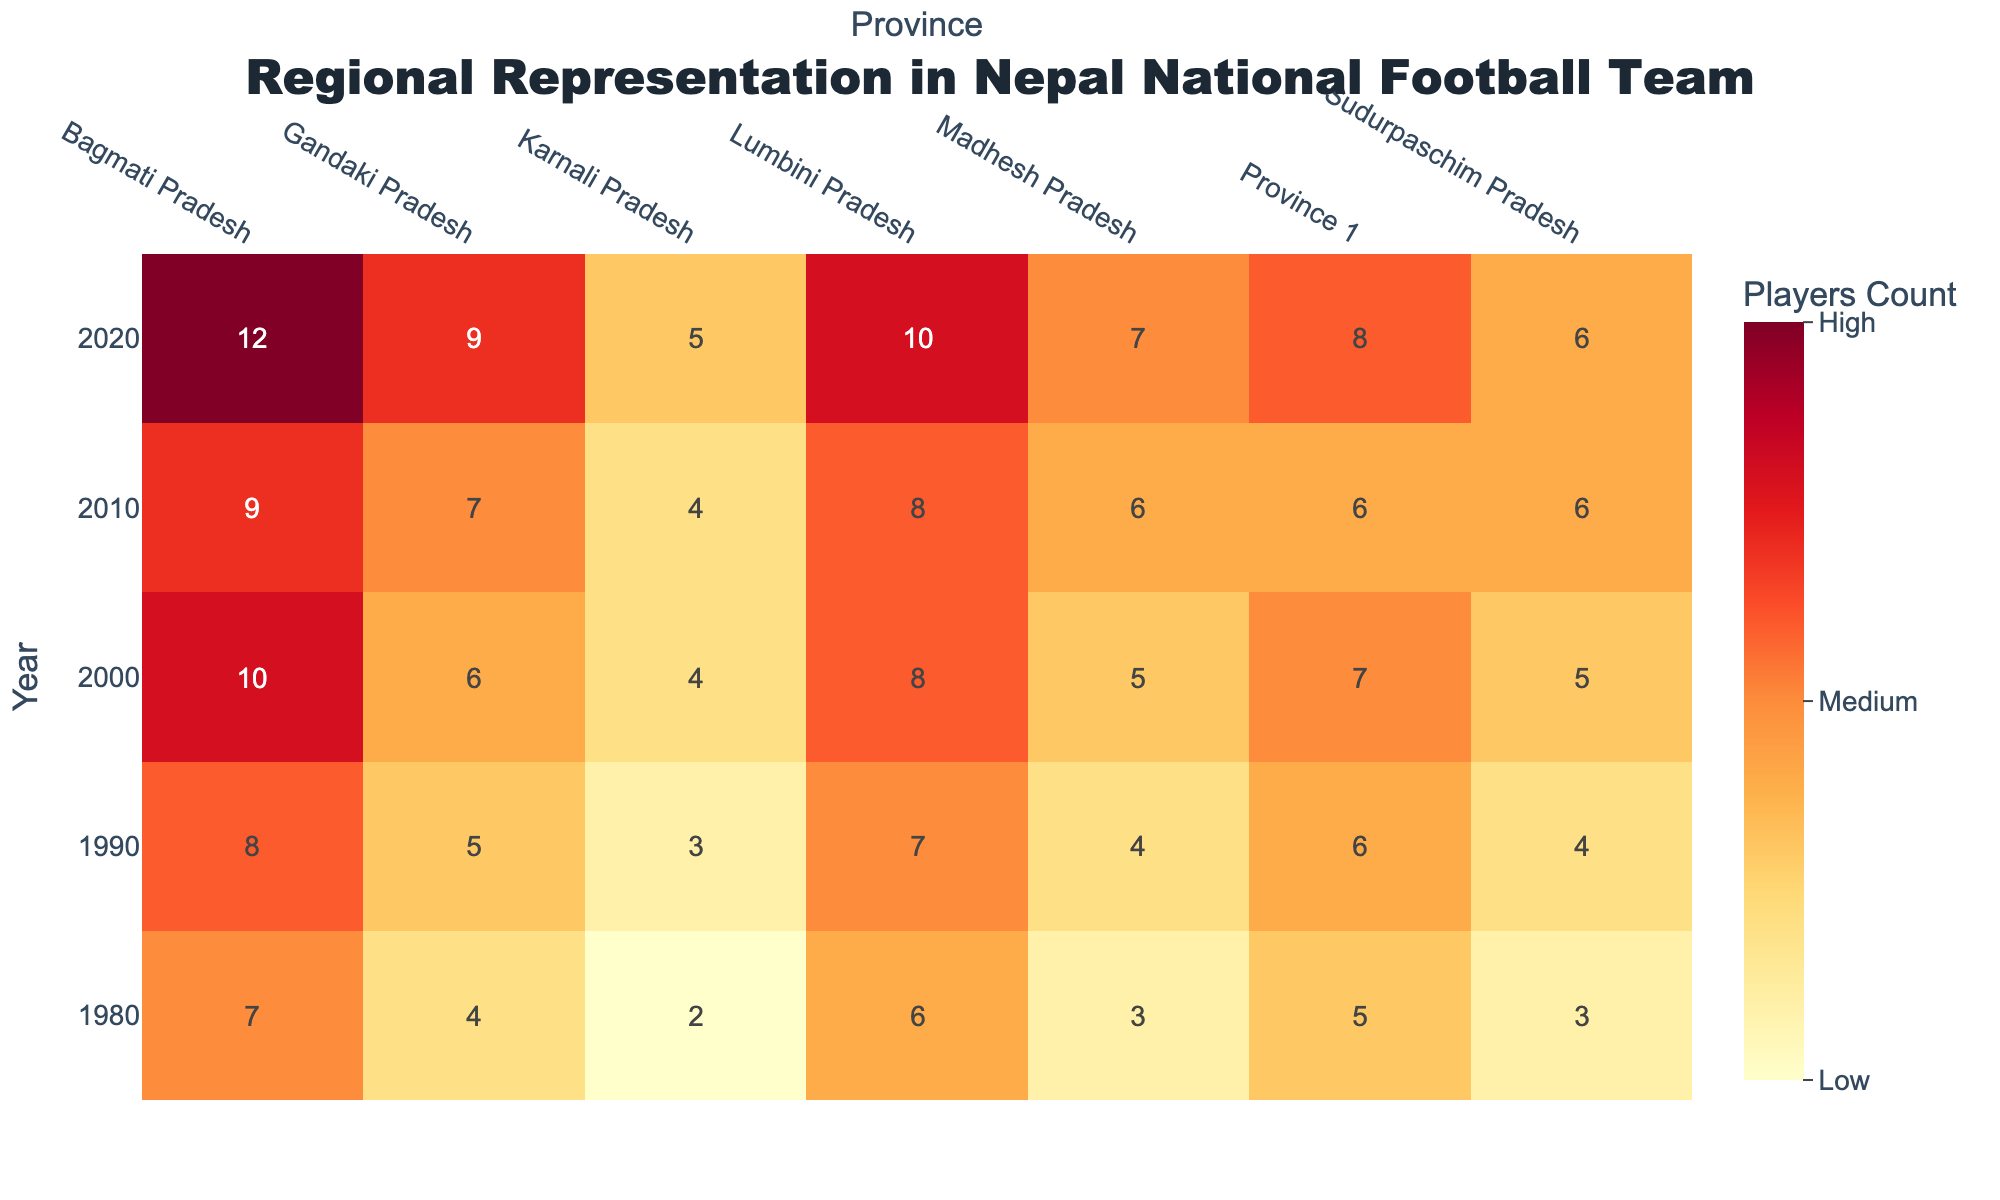What is the title of the heatmap? The title is usually displayed at the top of the figure. In this case, it reads "Regional Representation in Nepal National Football Team".
Answer: Regional Representation in Nepal National Football Team Which province had the highest number of players in 2020? The heatmap shows a high number of players from "Bagmati Pradesh" in 2020. This is indicated by the brightest color shade in the column corresponding to "2020".
Answer: Bagmati Pradesh How many decades are represented in the heatmap? By observing the y-axis of the heatmap, we can count the unique years listed. The years shown are 1980, 1990, 2000, 2010, and 2020, which makes five decades.
Answer: 5 Which region showed the most consistent representation across all decades? To determine the most consistent representation, we look for regions with relatively uniform shading across all years. "Karnali Pradesh," with its consistently low (darker) counts across all years, shows the most consistency.
Answer: Karnali Pradesh In which decade did "Province 1" see the highest increase in regional representation compared to the previous decade? By comparing the player counts for "Province 1" across decades, we see the highest increase from 1990 (6 players) to 2000 (7 players), indicating an increase of 1 player.
Answer: 2000 Compare the number of players from "Lumbini Pradesh" in 2000 and 2020. Did it increase or decrease? Looking at the heatmap, we see "Lumbini Pradesh" had a count of 8 in 2000 and a count of 10 in 2020, showing an increase.
Answer: Increased What is the difference in the number of players between "Madhesh Pradesh" and "Sudurpaschim Pradesh" in 1980? In 1980, "Madhesh Pradesh" had 3 players and "Sudurpaschim Pradesh" had 3 players as well. The difference is calculated as 3 - 3 = 0.
Answer: 0 Which region had the least representation in 2010? By examining the colors in the 2010 row, the region with the darkest shade corresponds to "Karnali Pradesh," indicating it had the least representation.
Answer: Karnali Pradesh Identify the region with the highest overall increase in player count from 1980 to 2020. The player counts over time can be compared from 1980 to 2020. "Bagmati Pradesh" shows an increase from 7 players in 1980 to 12 players in 2020, an overall increase of 5 players.
Answer: Bagmati Pradesh What trend do you observe in the representation of "Gandaki Pradesh" as the years progress? Observing the heatmap, "Gandaki Pradesh" shows a consistent increase in player counts over the decades, indicating a growing trend in representation.
Answer: Increasing trend 